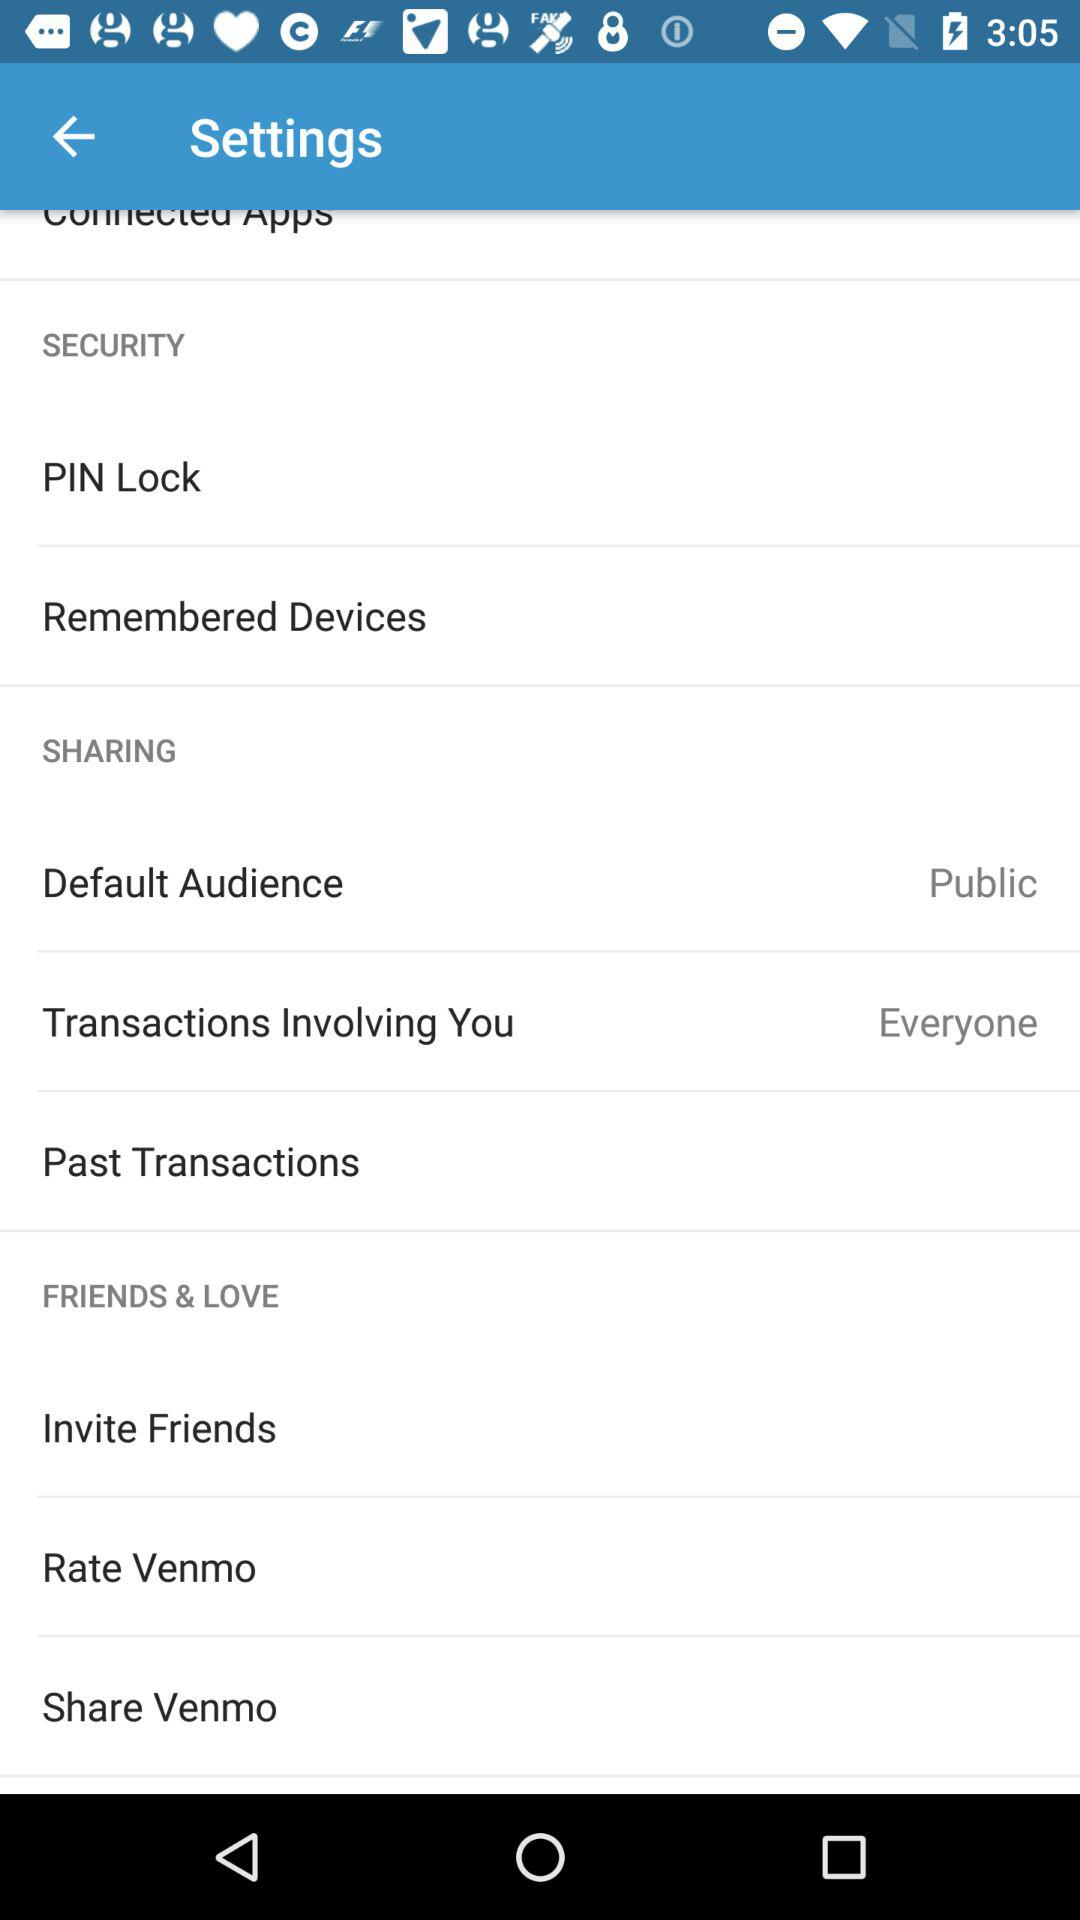How many items are in the Sharing section?
Answer the question using a single word or phrase. 3 